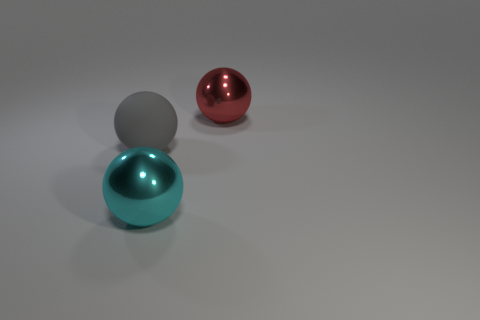Is the large sphere behind the large gray rubber object made of the same material as the gray ball?
Give a very brief answer. No. Are there any other things that have the same material as the gray object?
Keep it short and to the point. No. How many large things are blue shiny things or gray rubber things?
Ensure brevity in your answer.  1. There is a shiny thing in front of the red metal thing; is it the same shape as the shiny thing on the right side of the large cyan ball?
Your response must be concise. Yes. What is the sphere to the left of the large cyan shiny object made of?
Ensure brevity in your answer.  Rubber. How many red objects are either rubber things or balls?
Ensure brevity in your answer.  1. Is the red sphere made of the same material as the large ball that is in front of the big gray ball?
Offer a terse response. Yes. Is the number of large red spheres that are in front of the matte thing the same as the number of large things on the left side of the cyan metal ball?
Your response must be concise. No. There is a gray rubber ball; is its size the same as the metal object that is left of the red ball?
Offer a very short reply. Yes. Is the number of balls that are on the left side of the large cyan ball greater than the number of tiny cubes?
Offer a very short reply. Yes. 